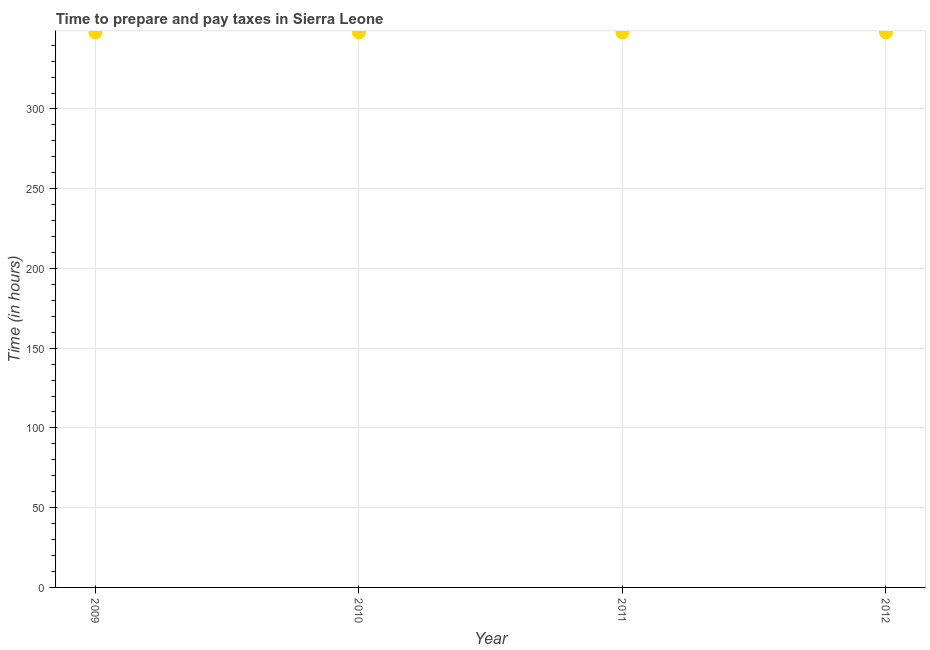What is the time to prepare and pay taxes in 2012?
Keep it short and to the point. 348. Across all years, what is the maximum time to prepare and pay taxes?
Provide a short and direct response. 348. Across all years, what is the minimum time to prepare and pay taxes?
Provide a short and direct response. 348. What is the sum of the time to prepare and pay taxes?
Give a very brief answer. 1392. What is the average time to prepare and pay taxes per year?
Give a very brief answer. 348. What is the median time to prepare and pay taxes?
Make the answer very short. 348. Do a majority of the years between 2010 and 2012 (inclusive) have time to prepare and pay taxes greater than 210 hours?
Ensure brevity in your answer.  Yes. What is the ratio of the time to prepare and pay taxes in 2010 to that in 2011?
Make the answer very short. 1. Is the time to prepare and pay taxes in 2010 less than that in 2011?
Ensure brevity in your answer.  No. Is the difference between the time to prepare and pay taxes in 2011 and 2012 greater than the difference between any two years?
Provide a short and direct response. Yes. What is the difference between the highest and the lowest time to prepare and pay taxes?
Your answer should be very brief. 0. Does the time to prepare and pay taxes monotonically increase over the years?
Offer a very short reply. No. How many years are there in the graph?
Your answer should be very brief. 4. Are the values on the major ticks of Y-axis written in scientific E-notation?
Offer a very short reply. No. Does the graph contain any zero values?
Keep it short and to the point. No. What is the title of the graph?
Your answer should be very brief. Time to prepare and pay taxes in Sierra Leone. What is the label or title of the Y-axis?
Provide a succinct answer. Time (in hours). What is the Time (in hours) in 2009?
Keep it short and to the point. 348. What is the Time (in hours) in 2010?
Keep it short and to the point. 348. What is the Time (in hours) in 2011?
Offer a very short reply. 348. What is the Time (in hours) in 2012?
Offer a very short reply. 348. What is the difference between the Time (in hours) in 2009 and 2012?
Keep it short and to the point. 0. What is the difference between the Time (in hours) in 2011 and 2012?
Ensure brevity in your answer.  0. What is the ratio of the Time (in hours) in 2009 to that in 2011?
Make the answer very short. 1. What is the ratio of the Time (in hours) in 2009 to that in 2012?
Offer a terse response. 1. What is the ratio of the Time (in hours) in 2010 to that in 2011?
Keep it short and to the point. 1. What is the ratio of the Time (in hours) in 2011 to that in 2012?
Your answer should be compact. 1. 